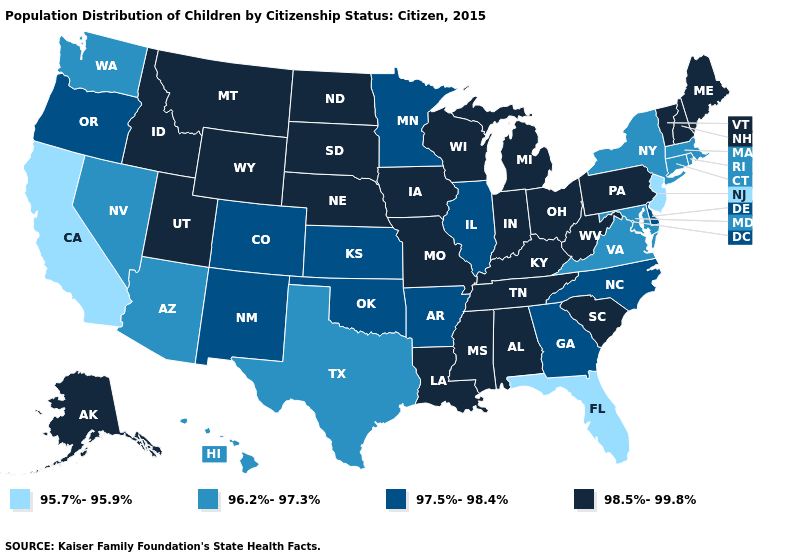Is the legend a continuous bar?
Quick response, please. No. Does Connecticut have a lower value than Wyoming?
Keep it brief. Yes. What is the lowest value in states that border Arkansas?
Write a very short answer. 96.2%-97.3%. Name the states that have a value in the range 97.5%-98.4%?
Quick response, please. Arkansas, Colorado, Delaware, Georgia, Illinois, Kansas, Minnesota, New Mexico, North Carolina, Oklahoma, Oregon. What is the highest value in states that border Washington?
Give a very brief answer. 98.5%-99.8%. Name the states that have a value in the range 96.2%-97.3%?
Be succinct. Arizona, Connecticut, Hawaii, Maryland, Massachusetts, Nevada, New York, Rhode Island, Texas, Virginia, Washington. Among the states that border West Virginia , does Virginia have the lowest value?
Give a very brief answer. Yes. Among the states that border West Virginia , which have the lowest value?
Concise answer only. Maryland, Virginia. Name the states that have a value in the range 95.7%-95.9%?
Short answer required. California, Florida, New Jersey. What is the value of North Carolina?
Be succinct. 97.5%-98.4%. What is the value of Florida?
Quick response, please. 95.7%-95.9%. What is the lowest value in the USA?
Concise answer only. 95.7%-95.9%. Does New Hampshire have the highest value in the USA?
Quick response, please. Yes. What is the lowest value in the USA?
Write a very short answer. 95.7%-95.9%. What is the value of Nevada?
Quick response, please. 96.2%-97.3%. 